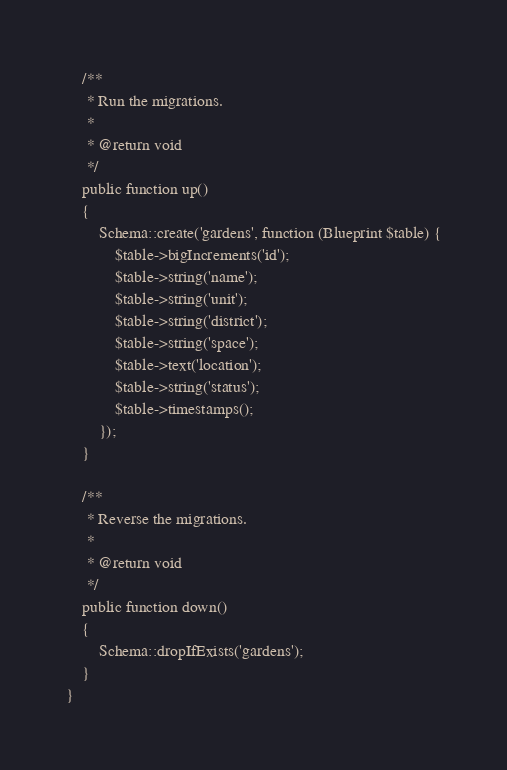Convert code to text. <code><loc_0><loc_0><loc_500><loc_500><_PHP_>    /**
     * Run the migrations.
     *
     * @return void
     */
    public function up()
    {
        Schema::create('gardens', function (Blueprint $table) {
            $table->bigIncrements('id');
            $table->string('name');
            $table->string('unit');
            $table->string('district');
            $table->string('space');
            $table->text('location');
            $table->string('status');
            $table->timestamps();
        });
    }

    /**
     * Reverse the migrations.
     *
     * @return void
     */
    public function down()
    {
        Schema::dropIfExists('gardens');
    }
}
</code> 